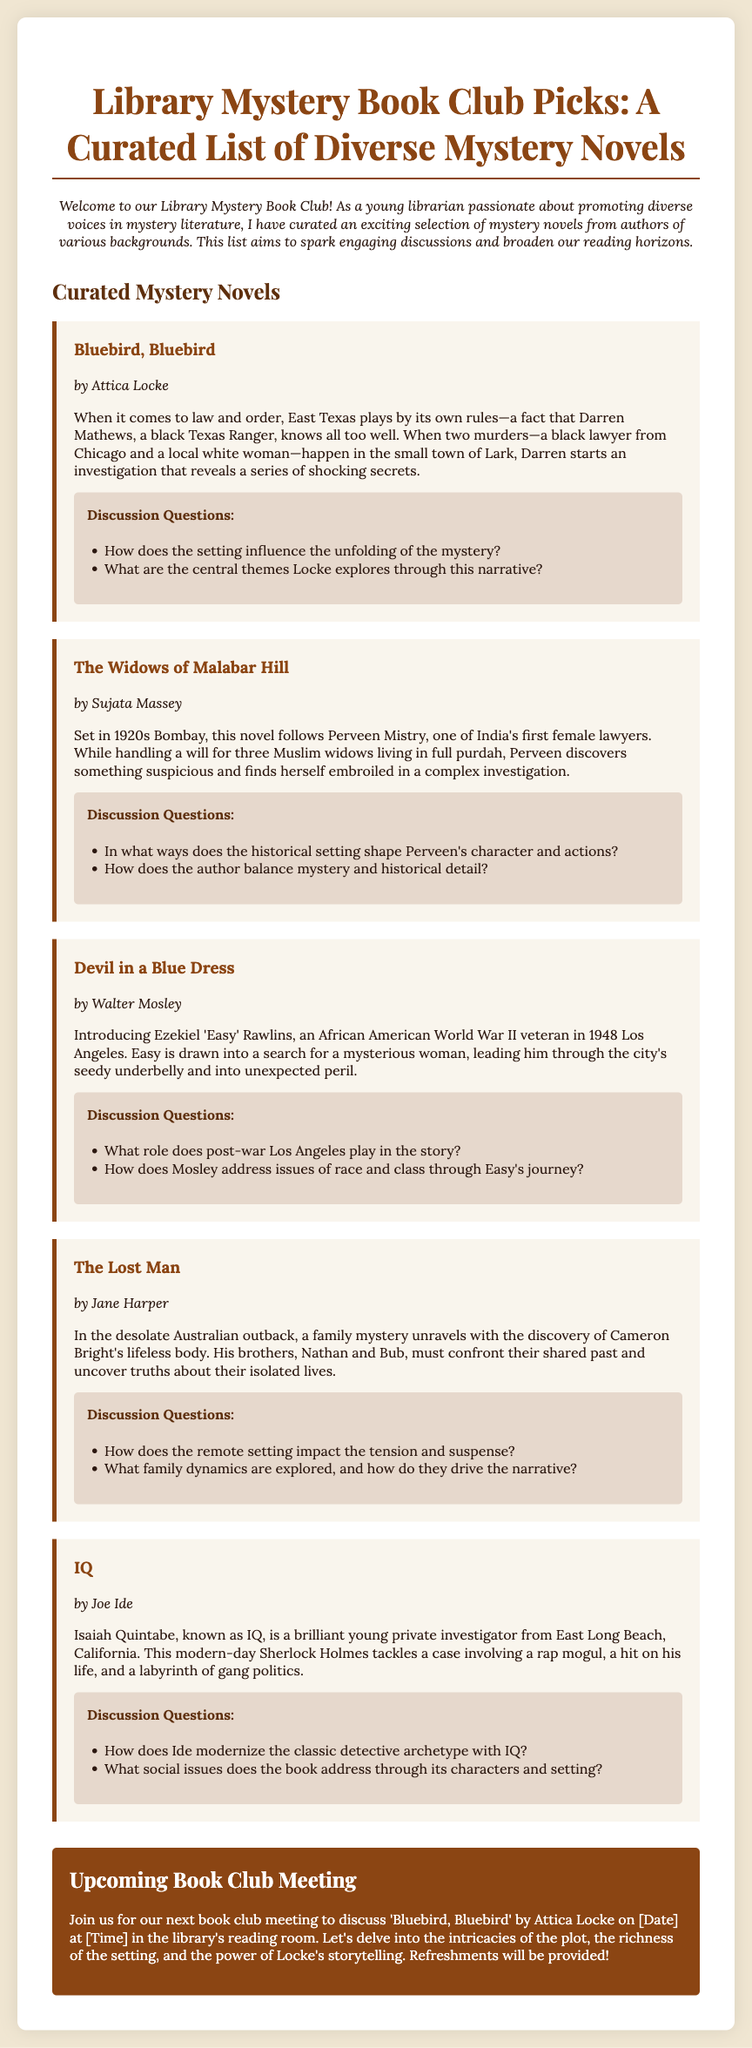What is the title of the document? The title of the document is prominently displayed at the top, indicating its subject matter.
Answer: Library Mystery Book Club Picks: A Curated List of Diverse Mystery Novels Who is the author of "Bluebird, Bluebird"? The author of "Bluebird, Bluebird" is listed under the book title.
Answer: Attica Locke What is the setting of "The Widows of Malabar Hill"? The setting is specified in the summary, reflecting the time and place in which the story unfolds.
Answer: 1920s Bombay What character is known as "IQ"? This character's name is mentioned in the summary section related to his investigative work.
Answer: Isaiah Quintabe How many discussion questions are provided for "Devil in a Blue Dress"? The number of discussion questions can be counted in the respective section under that book.
Answer: 2 What type of meeting is announced at the end of the document? The type of meeting is implied in the final section, mentioning the nature of the gathering.
Answer: Book Club Meeting What background does Ezekiel 'Easy' Rawlins have? The background information is provided in the summary section, detailing his previous experiences.
Answer: World War II veteran How does the author modernize the detective archetype in "IQ"? This requires reasoning about the author's approach, as noted in the discussion questions.
Answer: By introducing a young, brilliant private investigator What are refreshments provided during the meeting? The refreshments are mentioned in the closing paragraph regarding the upcoming meeting.
Answer: Yes 